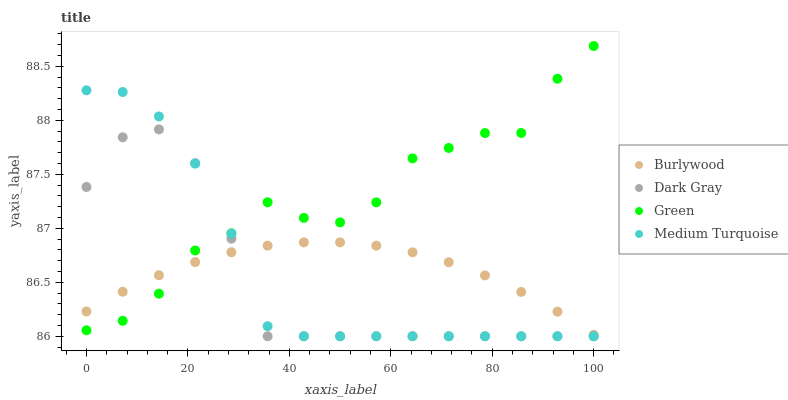Does Dark Gray have the minimum area under the curve?
Answer yes or no. Yes. Does Green have the maximum area under the curve?
Answer yes or no. Yes. Does Green have the minimum area under the curve?
Answer yes or no. No. Does Dark Gray have the maximum area under the curve?
Answer yes or no. No. Is Burlywood the smoothest?
Answer yes or no. Yes. Is Green the roughest?
Answer yes or no. Yes. Is Dark Gray the smoothest?
Answer yes or no. No. Is Dark Gray the roughest?
Answer yes or no. No. Does Dark Gray have the lowest value?
Answer yes or no. Yes. Does Green have the lowest value?
Answer yes or no. No. Does Green have the highest value?
Answer yes or no. Yes. Does Dark Gray have the highest value?
Answer yes or no. No. Does Burlywood intersect Green?
Answer yes or no. Yes. Is Burlywood less than Green?
Answer yes or no. No. Is Burlywood greater than Green?
Answer yes or no. No. 